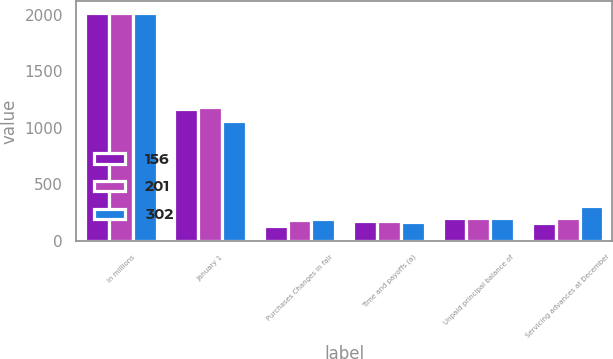Convert chart. <chart><loc_0><loc_0><loc_500><loc_500><stacked_bar_chart><ecel><fcel>In millions<fcel>January 1<fcel>Purchases Changes in fair<fcel>Time and payoffs (a)<fcel>Unpaid principal balance of<fcel>Servicing advances at December<nl><fcel>156<fcel>2018<fcel>1164<fcel>129<fcel>170<fcel>201<fcel>156<nl><fcel>201<fcel>2017<fcel>1182<fcel>185<fcel>175<fcel>201<fcel>201<nl><fcel>302<fcel>2016<fcel>1063<fcel>188<fcel>168<fcel>201<fcel>302<nl></chart> 